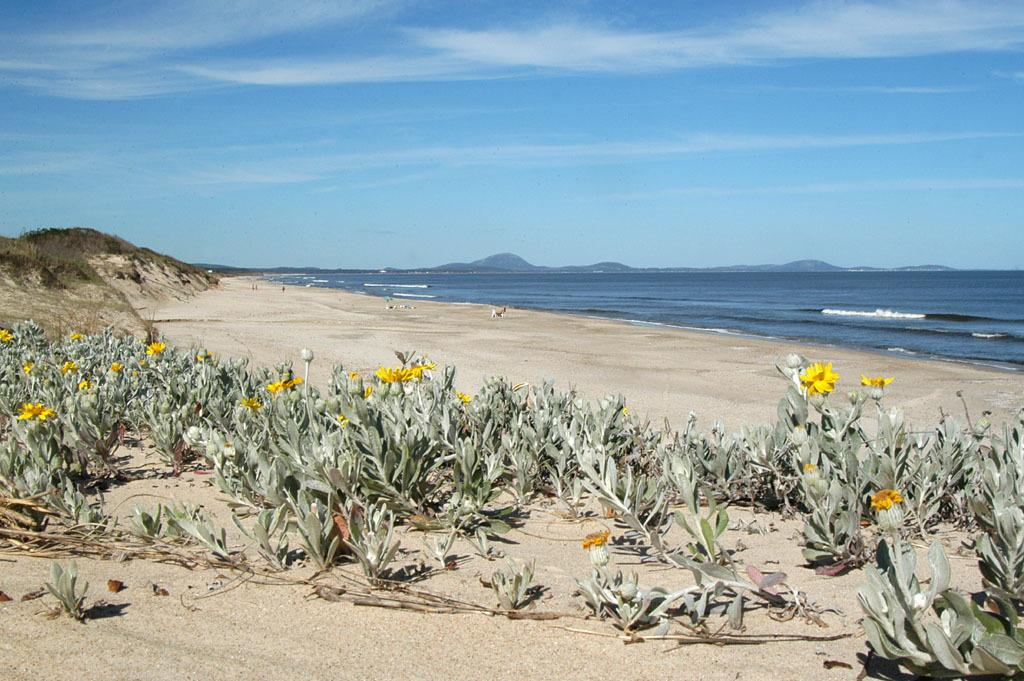What type of plants can be seen in the image? There are plants with flowers in the image. What covers the ground in the image? Grass is present on the ground in the image. Can you describe any objects in the image? There are objects in the image, but their specific nature is not mentioned in the facts. What can be seen in the water in the image? The facts do not mention anything specific about the water. What type of natural formation is present in the image? Mountains are present in the image. What is visible in the sky in the image? Clouds are visible in the sky in the image. How many bubbles are floating in the water in the image? There is no mention of bubbles in the image, so it is impossible to determine their number. 